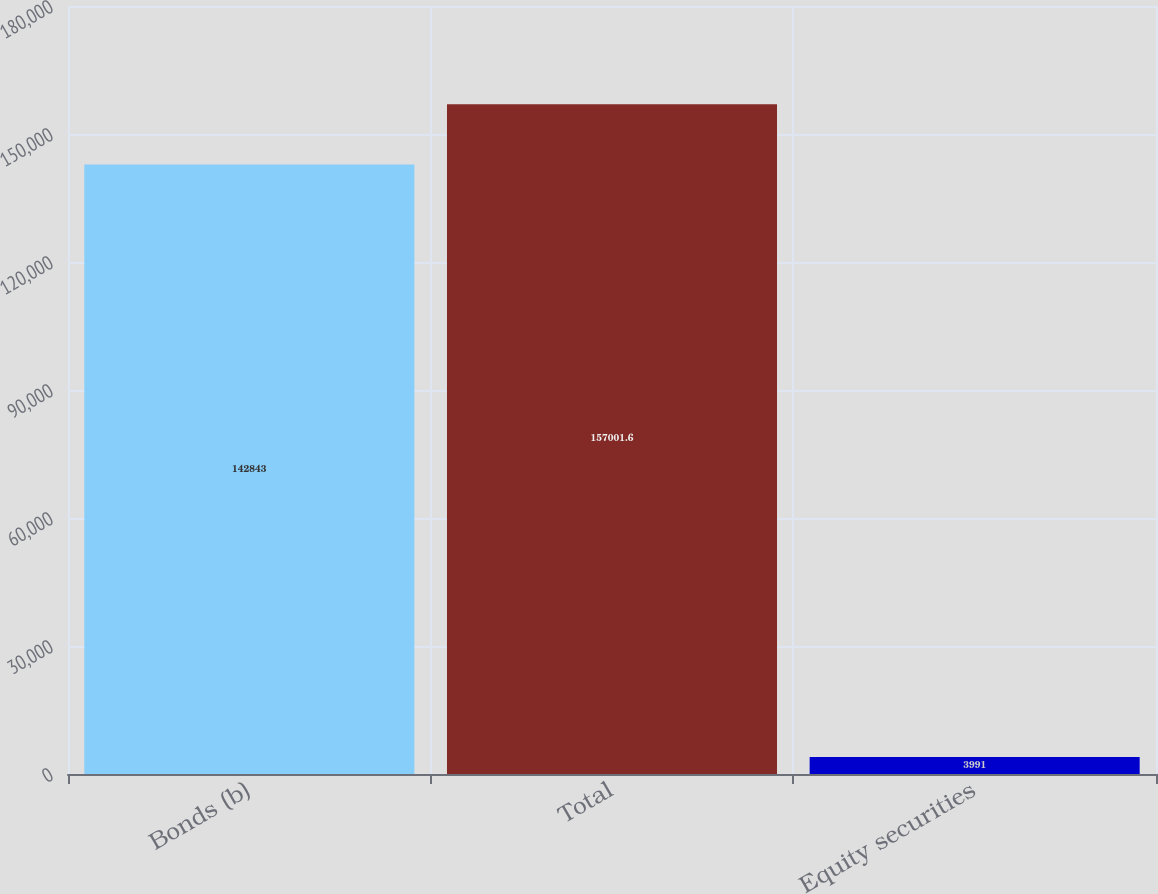Convert chart to OTSL. <chart><loc_0><loc_0><loc_500><loc_500><bar_chart><fcel>Bonds (b)<fcel>Total<fcel>Equity securities<nl><fcel>142843<fcel>157002<fcel>3991<nl></chart> 